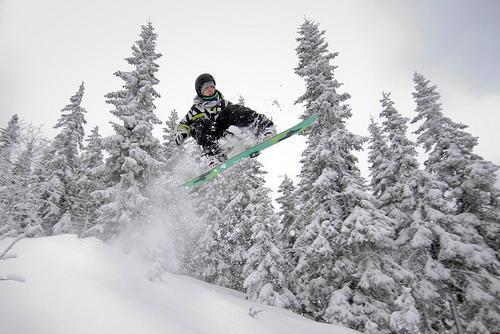How many people are in the picture?
Give a very brief answer. 1. 